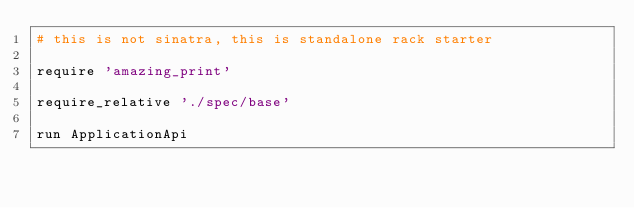<code> <loc_0><loc_0><loc_500><loc_500><_Ruby_># this is not sinatra, this is standalone rack starter

require 'amazing_print'

require_relative './spec/base'

run ApplicationApi</code> 